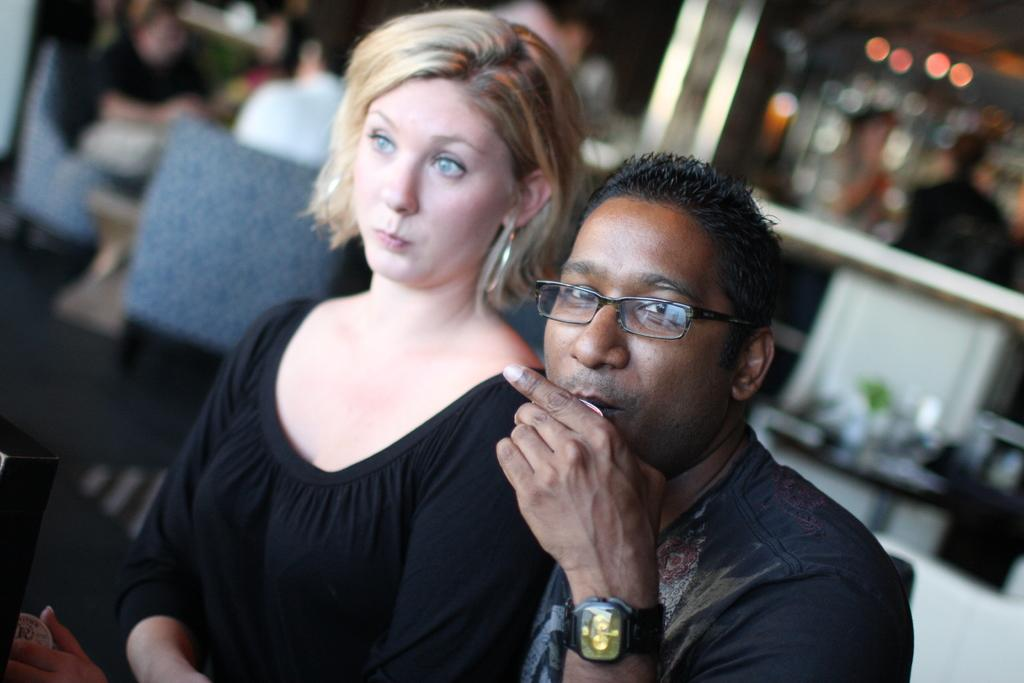How many people are present in the image? There are two people in the image. Can you describe one of the people in the image? One of the people is a man. What is the man holding in the image? The man is holding a cup. What can be seen in the background of the image? The background of the image is blurry, and there are chairs and people visible. What type of cherries are being served in the hospital attraction in the image? There is no hospital or attraction present in the image, nor are there any cherries visible. 